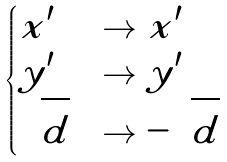Convert formula to latex. <formula><loc_0><loc_0><loc_500><loc_500>\begin{cases} x ^ { \prime } & \to x ^ { \prime } \\ y ^ { \prime } & \to y ^ { \prime } \\ \sqrt { d } & \to - \sqrt { d } \end{cases}</formula> 